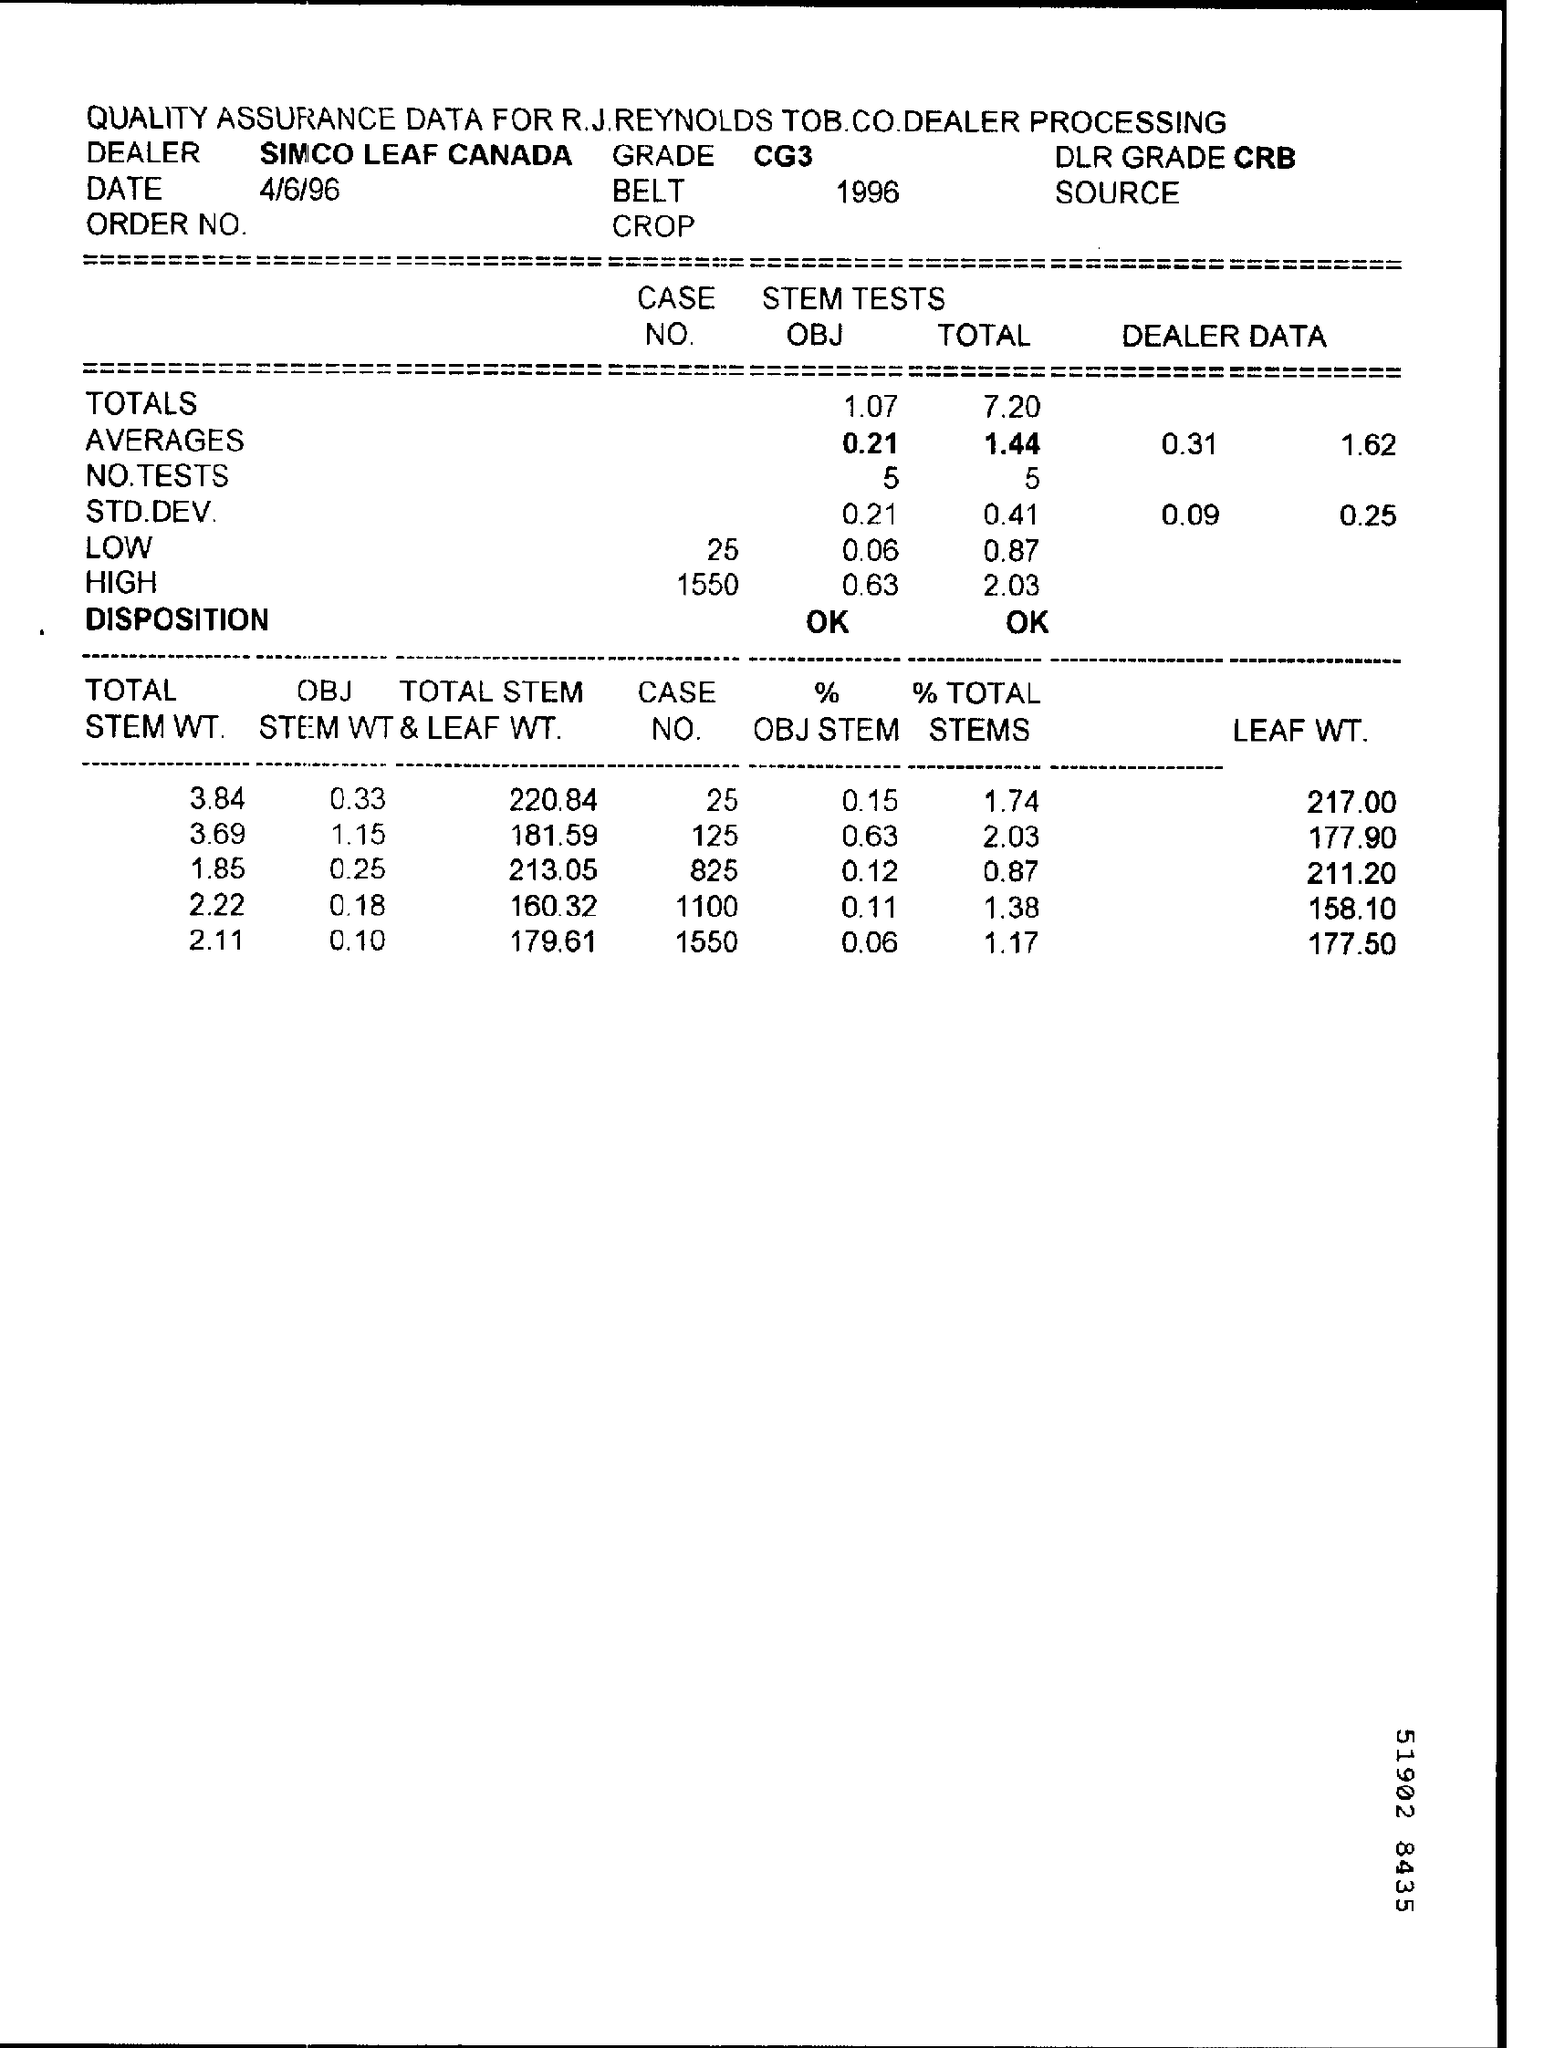When is the Memorandum dated on ?
Your response must be concise. 4/6/96. What is written in the Grade Field ?
Give a very brief answer. CG3. 